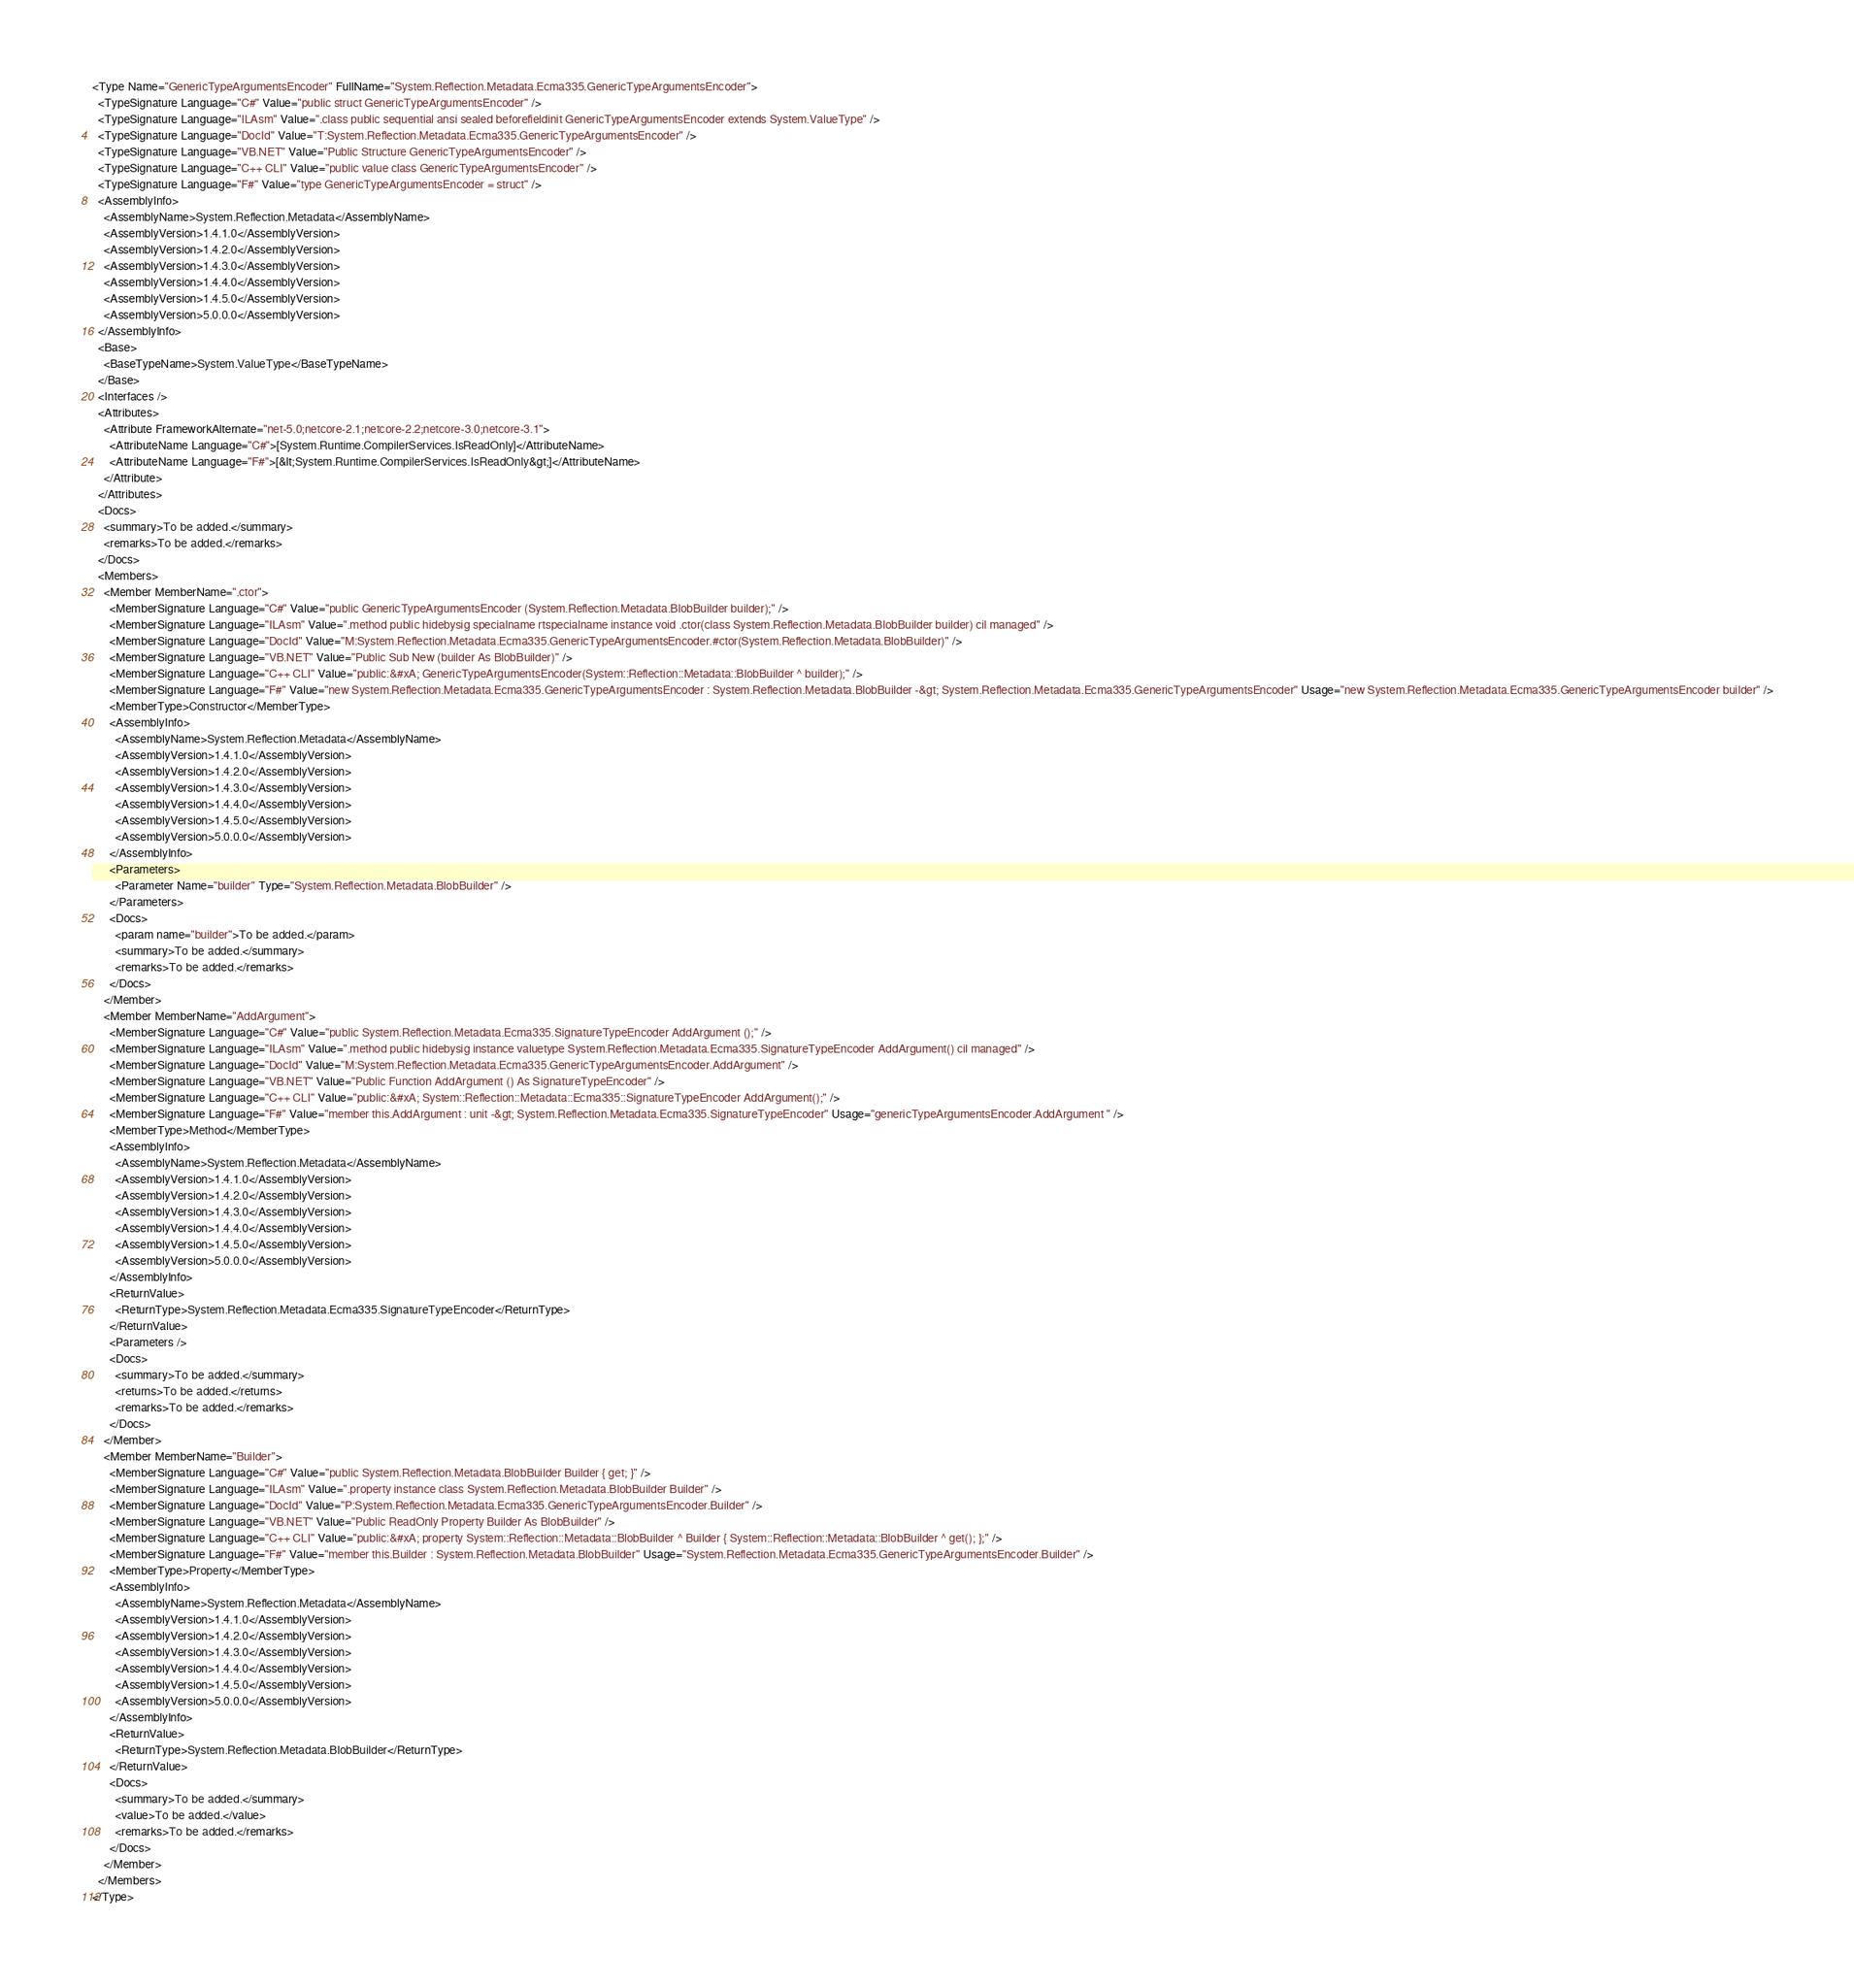<code> <loc_0><loc_0><loc_500><loc_500><_XML_><Type Name="GenericTypeArgumentsEncoder" FullName="System.Reflection.Metadata.Ecma335.GenericTypeArgumentsEncoder">
  <TypeSignature Language="C#" Value="public struct GenericTypeArgumentsEncoder" />
  <TypeSignature Language="ILAsm" Value=".class public sequential ansi sealed beforefieldinit GenericTypeArgumentsEncoder extends System.ValueType" />
  <TypeSignature Language="DocId" Value="T:System.Reflection.Metadata.Ecma335.GenericTypeArgumentsEncoder" />
  <TypeSignature Language="VB.NET" Value="Public Structure GenericTypeArgumentsEncoder" />
  <TypeSignature Language="C++ CLI" Value="public value class GenericTypeArgumentsEncoder" />
  <TypeSignature Language="F#" Value="type GenericTypeArgumentsEncoder = struct" />
  <AssemblyInfo>
    <AssemblyName>System.Reflection.Metadata</AssemblyName>
    <AssemblyVersion>1.4.1.0</AssemblyVersion>
    <AssemblyVersion>1.4.2.0</AssemblyVersion>
    <AssemblyVersion>1.4.3.0</AssemblyVersion>
    <AssemblyVersion>1.4.4.0</AssemblyVersion>
    <AssemblyVersion>1.4.5.0</AssemblyVersion>
    <AssemblyVersion>5.0.0.0</AssemblyVersion>
  </AssemblyInfo>
  <Base>
    <BaseTypeName>System.ValueType</BaseTypeName>
  </Base>
  <Interfaces />
  <Attributes>
    <Attribute FrameworkAlternate="net-5.0;netcore-2.1;netcore-2.2;netcore-3.0;netcore-3.1">
      <AttributeName Language="C#">[System.Runtime.CompilerServices.IsReadOnly]</AttributeName>
      <AttributeName Language="F#">[&lt;System.Runtime.CompilerServices.IsReadOnly&gt;]</AttributeName>
    </Attribute>
  </Attributes>
  <Docs>
    <summary>To be added.</summary>
    <remarks>To be added.</remarks>
  </Docs>
  <Members>
    <Member MemberName=".ctor">
      <MemberSignature Language="C#" Value="public GenericTypeArgumentsEncoder (System.Reflection.Metadata.BlobBuilder builder);" />
      <MemberSignature Language="ILAsm" Value=".method public hidebysig specialname rtspecialname instance void .ctor(class System.Reflection.Metadata.BlobBuilder builder) cil managed" />
      <MemberSignature Language="DocId" Value="M:System.Reflection.Metadata.Ecma335.GenericTypeArgumentsEncoder.#ctor(System.Reflection.Metadata.BlobBuilder)" />
      <MemberSignature Language="VB.NET" Value="Public Sub New (builder As BlobBuilder)" />
      <MemberSignature Language="C++ CLI" Value="public:&#xA; GenericTypeArgumentsEncoder(System::Reflection::Metadata::BlobBuilder ^ builder);" />
      <MemberSignature Language="F#" Value="new System.Reflection.Metadata.Ecma335.GenericTypeArgumentsEncoder : System.Reflection.Metadata.BlobBuilder -&gt; System.Reflection.Metadata.Ecma335.GenericTypeArgumentsEncoder" Usage="new System.Reflection.Metadata.Ecma335.GenericTypeArgumentsEncoder builder" />
      <MemberType>Constructor</MemberType>
      <AssemblyInfo>
        <AssemblyName>System.Reflection.Metadata</AssemblyName>
        <AssemblyVersion>1.4.1.0</AssemblyVersion>
        <AssemblyVersion>1.4.2.0</AssemblyVersion>
        <AssemblyVersion>1.4.3.0</AssemblyVersion>
        <AssemblyVersion>1.4.4.0</AssemblyVersion>
        <AssemblyVersion>1.4.5.0</AssemblyVersion>
        <AssemblyVersion>5.0.0.0</AssemblyVersion>
      </AssemblyInfo>
      <Parameters>
        <Parameter Name="builder" Type="System.Reflection.Metadata.BlobBuilder" />
      </Parameters>
      <Docs>
        <param name="builder">To be added.</param>
        <summary>To be added.</summary>
        <remarks>To be added.</remarks>
      </Docs>
    </Member>
    <Member MemberName="AddArgument">
      <MemberSignature Language="C#" Value="public System.Reflection.Metadata.Ecma335.SignatureTypeEncoder AddArgument ();" />
      <MemberSignature Language="ILAsm" Value=".method public hidebysig instance valuetype System.Reflection.Metadata.Ecma335.SignatureTypeEncoder AddArgument() cil managed" />
      <MemberSignature Language="DocId" Value="M:System.Reflection.Metadata.Ecma335.GenericTypeArgumentsEncoder.AddArgument" />
      <MemberSignature Language="VB.NET" Value="Public Function AddArgument () As SignatureTypeEncoder" />
      <MemberSignature Language="C++ CLI" Value="public:&#xA; System::Reflection::Metadata::Ecma335::SignatureTypeEncoder AddArgument();" />
      <MemberSignature Language="F#" Value="member this.AddArgument : unit -&gt; System.Reflection.Metadata.Ecma335.SignatureTypeEncoder" Usage="genericTypeArgumentsEncoder.AddArgument " />
      <MemberType>Method</MemberType>
      <AssemblyInfo>
        <AssemblyName>System.Reflection.Metadata</AssemblyName>
        <AssemblyVersion>1.4.1.0</AssemblyVersion>
        <AssemblyVersion>1.4.2.0</AssemblyVersion>
        <AssemblyVersion>1.4.3.0</AssemblyVersion>
        <AssemblyVersion>1.4.4.0</AssemblyVersion>
        <AssemblyVersion>1.4.5.0</AssemblyVersion>
        <AssemblyVersion>5.0.0.0</AssemblyVersion>
      </AssemblyInfo>
      <ReturnValue>
        <ReturnType>System.Reflection.Metadata.Ecma335.SignatureTypeEncoder</ReturnType>
      </ReturnValue>
      <Parameters />
      <Docs>
        <summary>To be added.</summary>
        <returns>To be added.</returns>
        <remarks>To be added.</remarks>
      </Docs>
    </Member>
    <Member MemberName="Builder">
      <MemberSignature Language="C#" Value="public System.Reflection.Metadata.BlobBuilder Builder { get; }" />
      <MemberSignature Language="ILAsm" Value=".property instance class System.Reflection.Metadata.BlobBuilder Builder" />
      <MemberSignature Language="DocId" Value="P:System.Reflection.Metadata.Ecma335.GenericTypeArgumentsEncoder.Builder" />
      <MemberSignature Language="VB.NET" Value="Public ReadOnly Property Builder As BlobBuilder" />
      <MemberSignature Language="C++ CLI" Value="public:&#xA; property System::Reflection::Metadata::BlobBuilder ^ Builder { System::Reflection::Metadata::BlobBuilder ^ get(); };" />
      <MemberSignature Language="F#" Value="member this.Builder : System.Reflection.Metadata.BlobBuilder" Usage="System.Reflection.Metadata.Ecma335.GenericTypeArgumentsEncoder.Builder" />
      <MemberType>Property</MemberType>
      <AssemblyInfo>
        <AssemblyName>System.Reflection.Metadata</AssemblyName>
        <AssemblyVersion>1.4.1.0</AssemblyVersion>
        <AssemblyVersion>1.4.2.0</AssemblyVersion>
        <AssemblyVersion>1.4.3.0</AssemblyVersion>
        <AssemblyVersion>1.4.4.0</AssemblyVersion>
        <AssemblyVersion>1.4.5.0</AssemblyVersion>
        <AssemblyVersion>5.0.0.0</AssemblyVersion>
      </AssemblyInfo>
      <ReturnValue>
        <ReturnType>System.Reflection.Metadata.BlobBuilder</ReturnType>
      </ReturnValue>
      <Docs>
        <summary>To be added.</summary>
        <value>To be added.</value>
        <remarks>To be added.</remarks>
      </Docs>
    </Member>
  </Members>
</Type>
</code> 